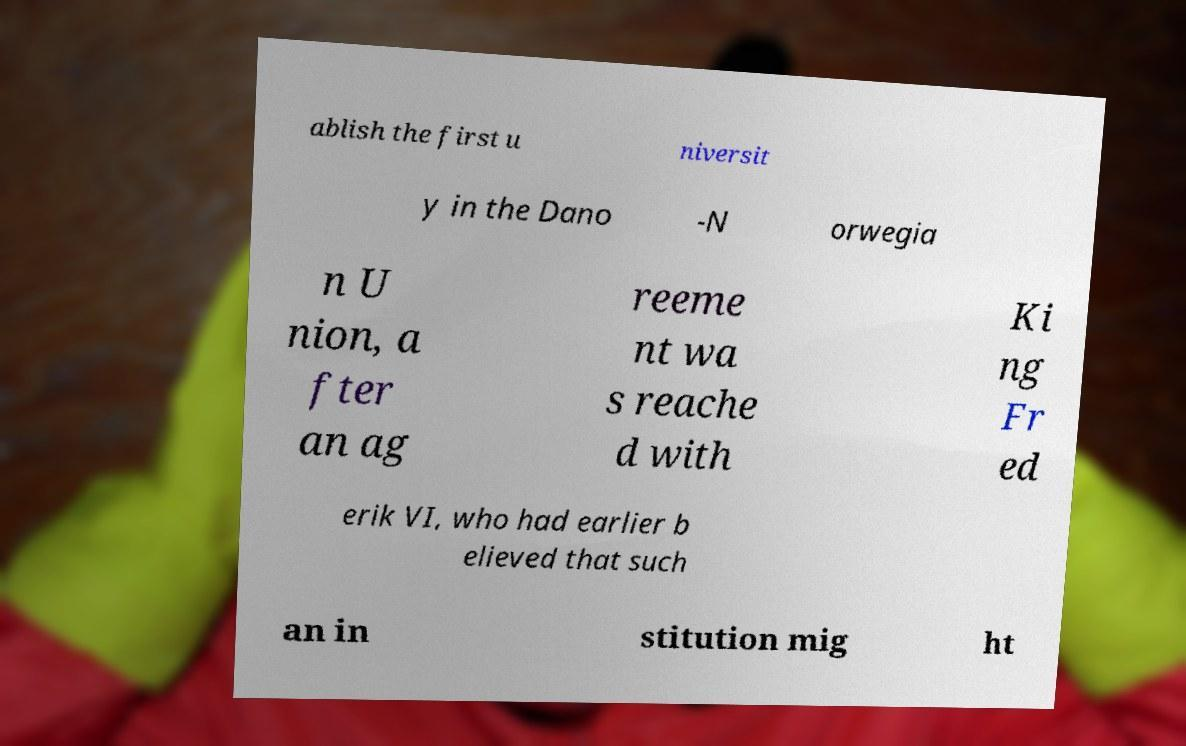Could you extract and type out the text from this image? ablish the first u niversit y in the Dano -N orwegia n U nion, a fter an ag reeme nt wa s reache d with Ki ng Fr ed erik VI, who had earlier b elieved that such an in stitution mig ht 